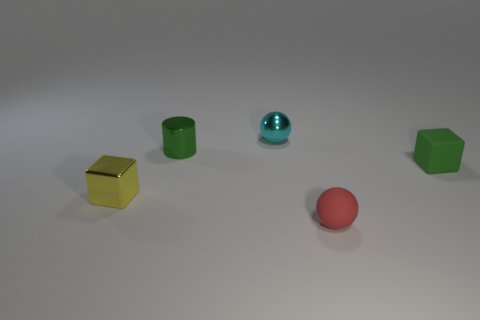Add 5 tiny gray matte cylinders. How many objects exist? 10 Subtract all blocks. How many objects are left? 3 Subtract all tiny green rubber objects. Subtract all red rubber balls. How many objects are left? 3 Add 2 rubber blocks. How many rubber blocks are left? 3 Add 3 tiny spheres. How many tiny spheres exist? 5 Subtract 0 blue cylinders. How many objects are left? 5 